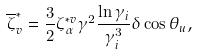<formula> <loc_0><loc_0><loc_500><loc_500>\overline { \zeta } _ { v } ^ { * } = \frac { 3 } { 2 } \zeta _ { \alpha } ^ { * v } \gamma ^ { 2 } \frac { \ln \gamma _ { i } } { \gamma _ { i } ^ { 3 } } \delta \cos \theta _ { u } ,</formula> 